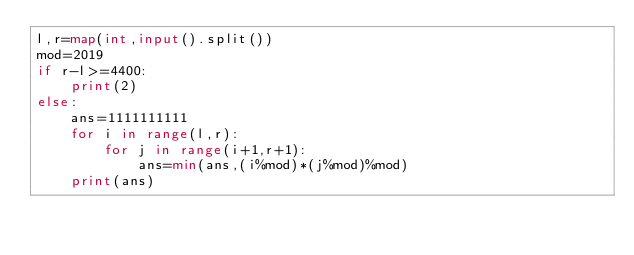<code> <loc_0><loc_0><loc_500><loc_500><_Python_>l,r=map(int,input().split())
mod=2019
if r-l>=4400:
    print(2)
else:
    ans=1111111111
    for i in range(l,r):
        for j in range(i+1,r+1):
            ans=min(ans,(i%mod)*(j%mod)%mod)
    print(ans)</code> 